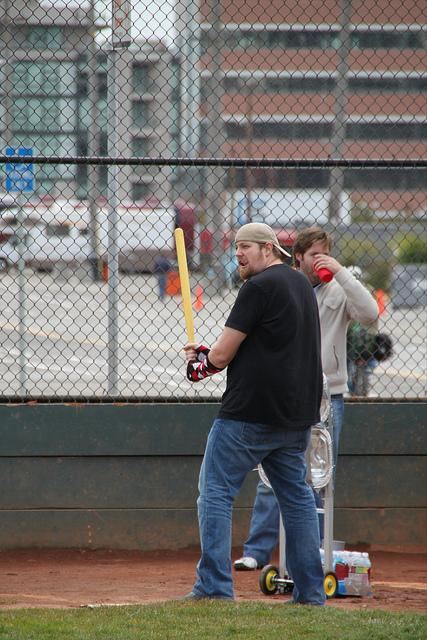What is the man in the black ready to do?

Choices:
A) swing
B) serve
C) dunk
D) sit swing 